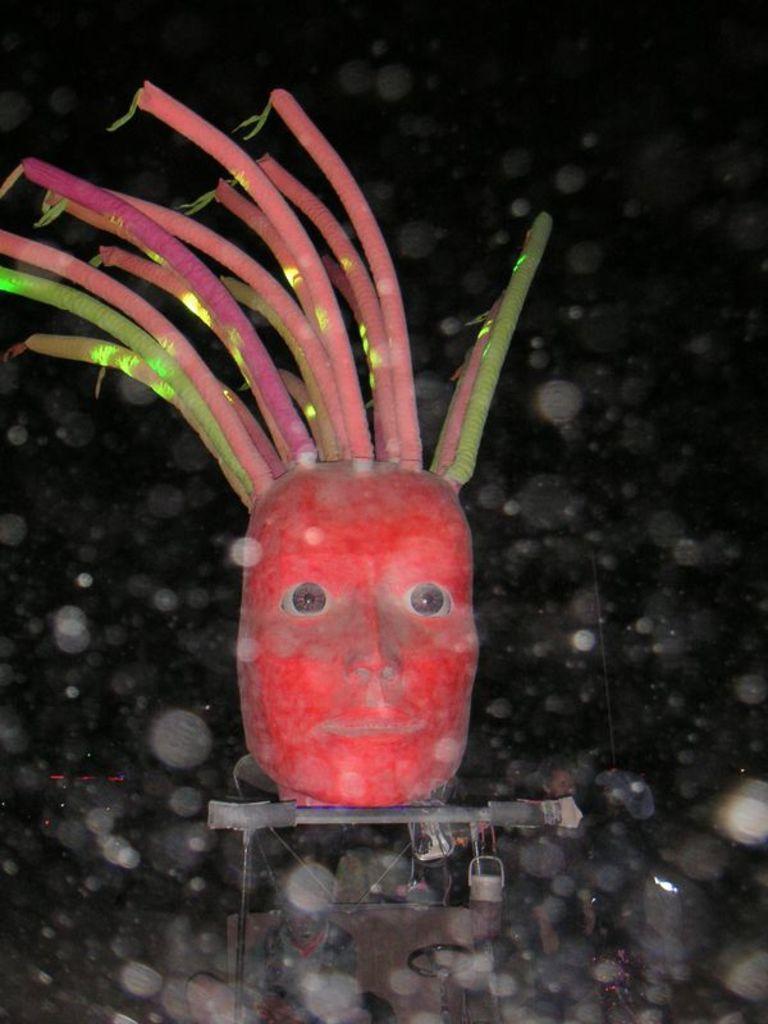Describe this image in one or two sentences. In this picture we can see a person's face. 